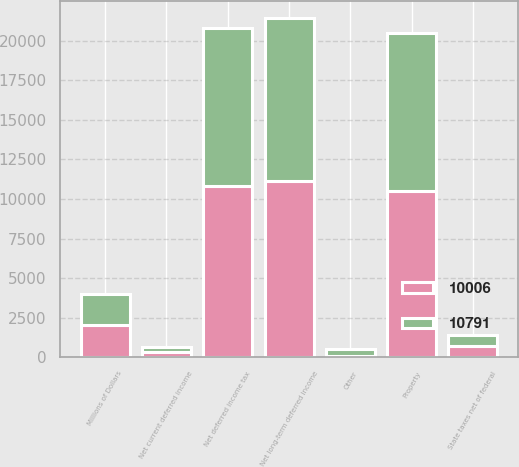Convert chart. <chart><loc_0><loc_0><loc_500><loc_500><stacked_bar_chart><ecel><fcel>Millions of Dollars<fcel>Net current deferred income<fcel>Property<fcel>State taxes net of federal<fcel>Other<fcel>Net long-term deferred income<fcel>Net deferred income tax<nl><fcel>10006<fcel>2009<fcel>339<fcel>10494<fcel>726<fcel>90<fcel>11130<fcel>10791<nl><fcel>10791<fcel>2008<fcel>276<fcel>10006<fcel>675<fcel>399<fcel>10282<fcel>10006<nl></chart> 